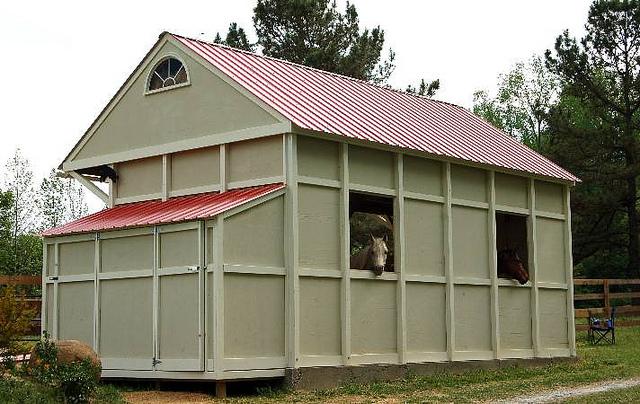What shape is the window at the top side of the building?
Write a very short answer. Half circle. What color is the roof?
Quick response, please. Red. How many windows are shown on the front of the house?
Write a very short answer. 2. How many horses are looking at the camera?
Be succinct. 1. 